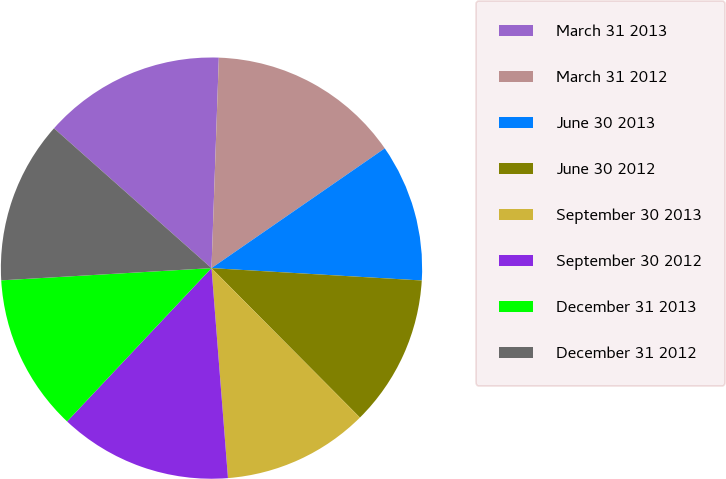Convert chart to OTSL. <chart><loc_0><loc_0><loc_500><loc_500><pie_chart><fcel>March 31 2013<fcel>March 31 2012<fcel>June 30 2013<fcel>June 30 2012<fcel>September 30 2013<fcel>September 30 2012<fcel>December 31 2013<fcel>December 31 2012<nl><fcel>14.0%<fcel>14.82%<fcel>10.56%<fcel>11.62%<fcel>11.2%<fcel>13.27%<fcel>12.05%<fcel>12.48%<nl></chart> 